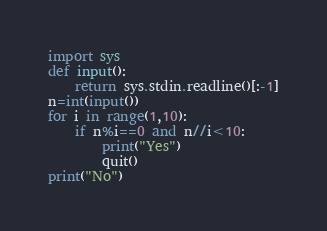Convert code to text. <code><loc_0><loc_0><loc_500><loc_500><_Python_>import sys
def input():
    return sys.stdin.readline()[:-1]
n=int(input())
for i in range(1,10):
    if n%i==0 and n//i<10:
        print("Yes")
        quit()
print("No")</code> 